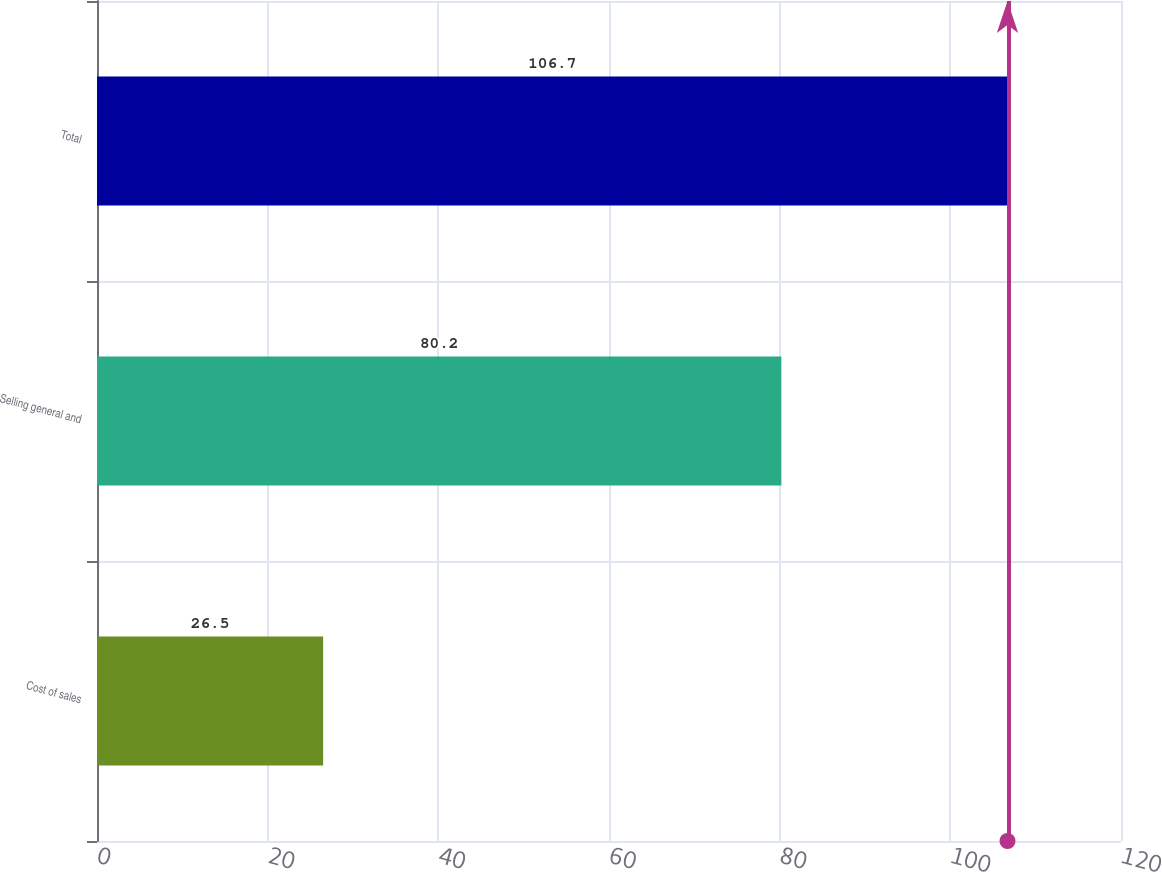Convert chart to OTSL. <chart><loc_0><loc_0><loc_500><loc_500><bar_chart><fcel>Cost of sales<fcel>Selling general and<fcel>Total<nl><fcel>26.5<fcel>80.2<fcel>106.7<nl></chart> 